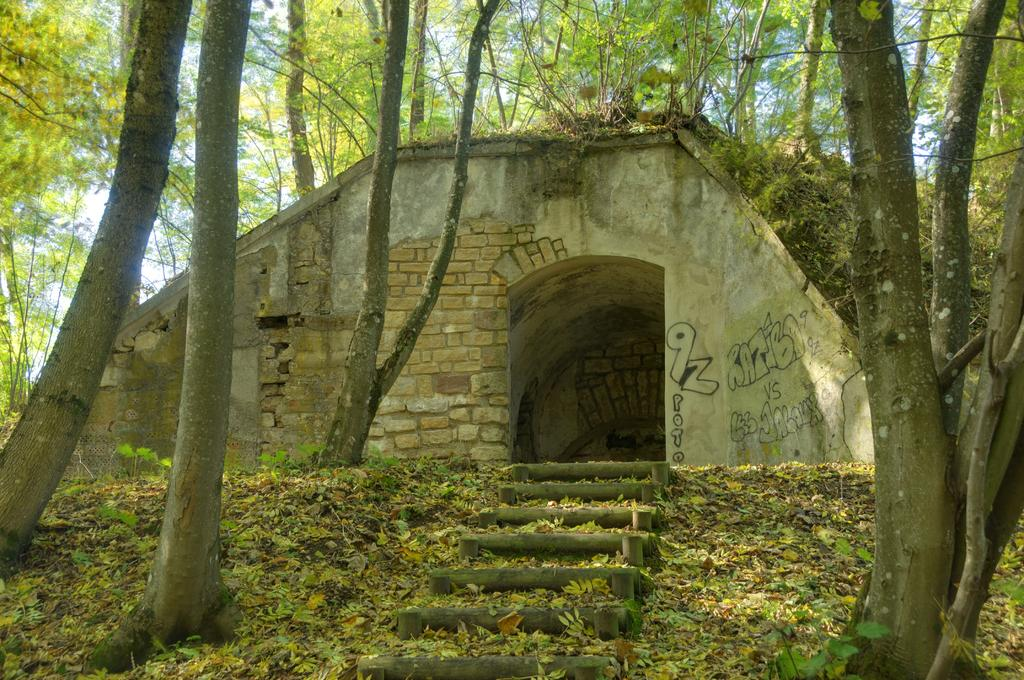What type of structure can be seen in the image? There are stairs and a concrete structure made up of bricks in the image. What is present on the ground in the image? There are leaves on the ground in the image. What type of vegetation is visible in the image? There are trees in the image, and trees are also visible in the background. What can be seen in the sky in the image? The sky is visible in the background of the image. Can you see a zipper on the trees in the image? There is no zipper present on the trees in the image. Is there an airplane flying in the sky in the image? There is no airplane visible in the sky in the image. 